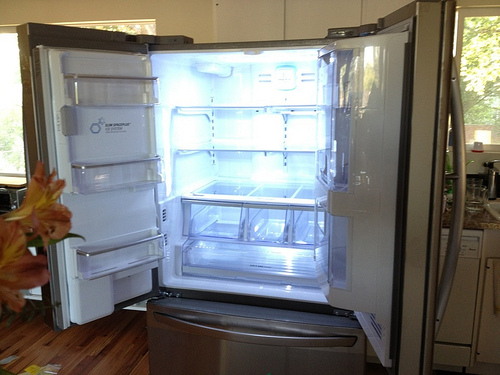Please provide the bounding box coordinate of the region this sentence describes: the handle is silver. A more precise set of bounding box coordinates for the silver refrigerator handle would be [0.8, 0.25, 0.83, 0.75], which better captures the vertical handle on the right door. 